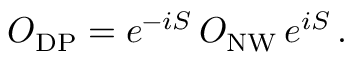Convert formula to latex. <formula><loc_0><loc_0><loc_500><loc_500>O _ { D P } = e ^ { - i S } \, O _ { N W } \, e ^ { i S } \, .</formula> 